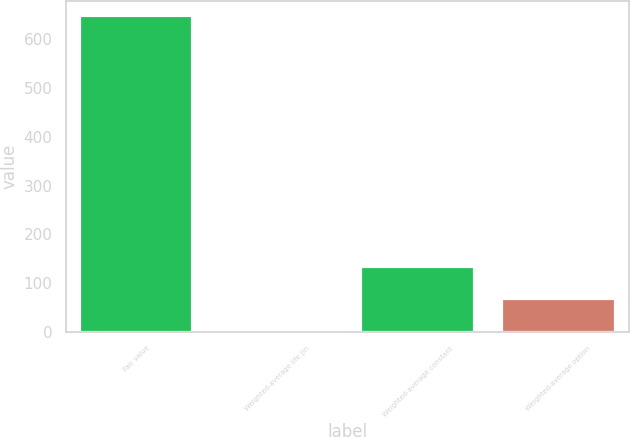Convert chart. <chart><loc_0><loc_0><loc_500><loc_500><bar_chart><fcel>Fair value<fcel>Weighted-average life (in<fcel>Weighted-average constant<fcel>Weighted-average option<nl><fcel>647<fcel>3.6<fcel>132.28<fcel>67.94<nl></chart> 